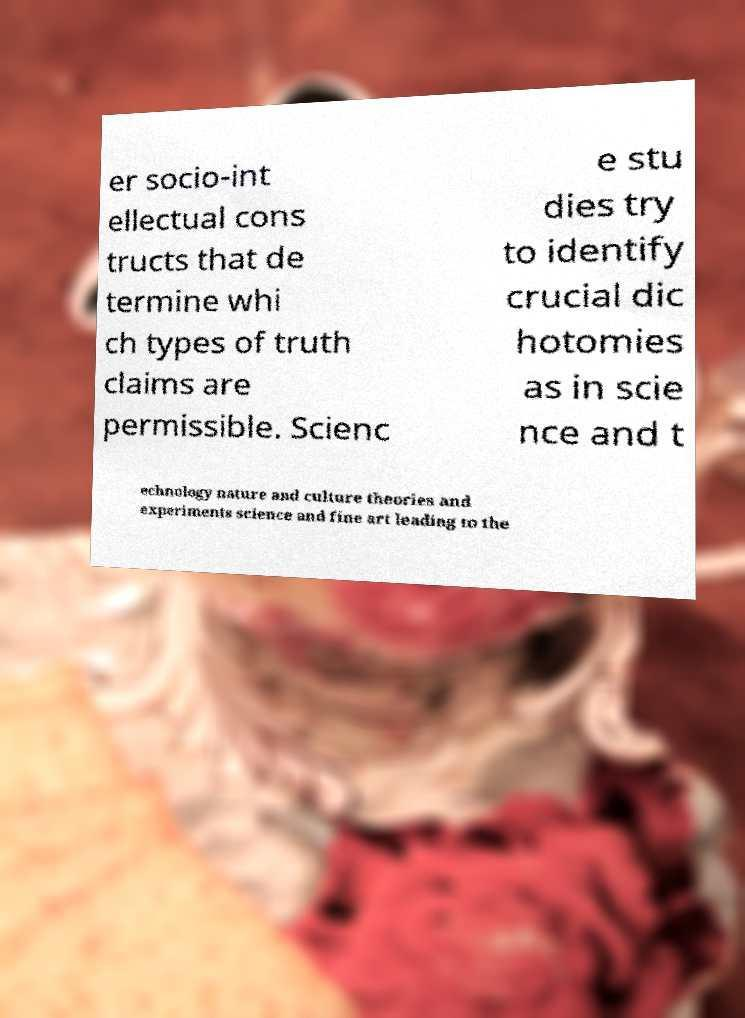For documentation purposes, I need the text within this image transcribed. Could you provide that? er socio-int ellectual cons tructs that de termine whi ch types of truth claims are permissible. Scienc e stu dies try to identify crucial dic hotomies as in scie nce and t echnology nature and culture theories and experiments science and fine art leading to the 